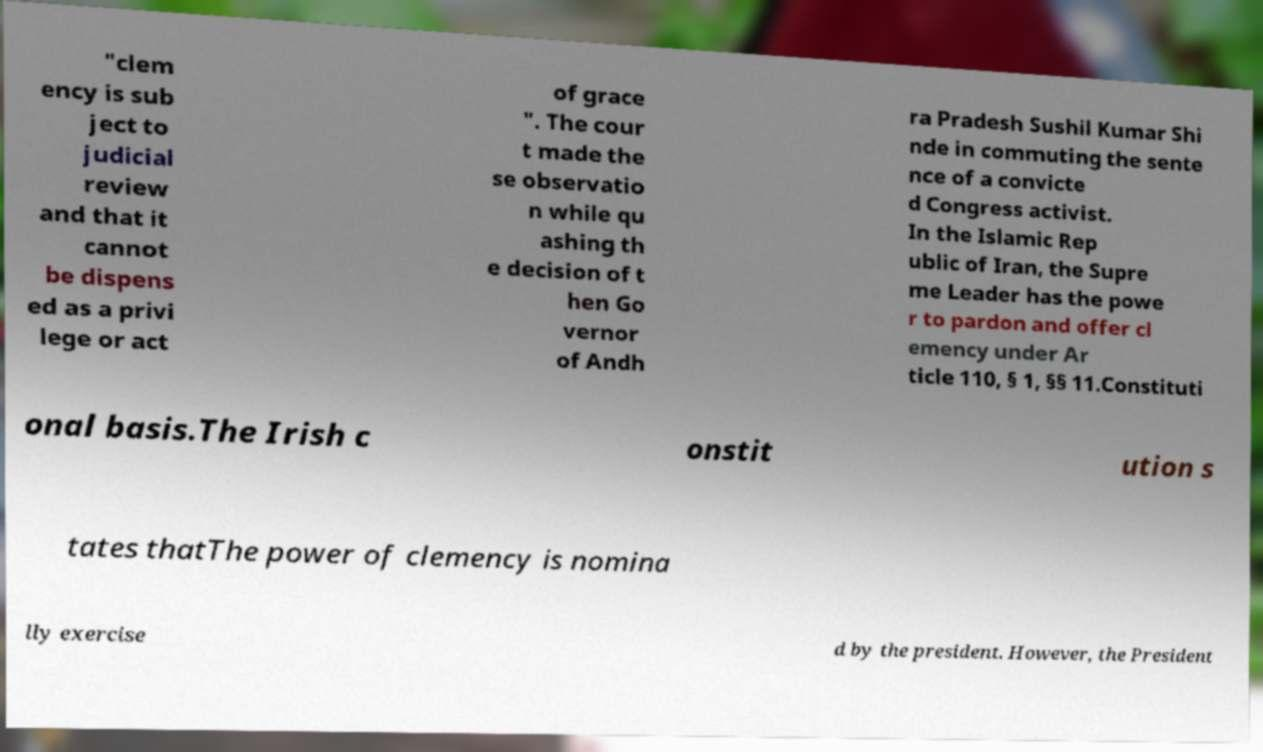I need the written content from this picture converted into text. Can you do that? "clem ency is sub ject to judicial review and that it cannot be dispens ed as a privi lege or act of grace ". The cour t made the se observatio n while qu ashing th e decision of t hen Go vernor of Andh ra Pradesh Sushil Kumar Shi nde in commuting the sente nce of a convicte d Congress activist. In the Islamic Rep ublic of Iran, the Supre me Leader has the powe r to pardon and offer cl emency under Ar ticle 110, § 1, §§ 11.Constituti onal basis.The Irish c onstit ution s tates thatThe power of clemency is nomina lly exercise d by the president. However, the President 